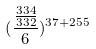<formula> <loc_0><loc_0><loc_500><loc_500>( \frac { \frac { 3 3 4 } { 3 3 2 } } { 6 } ) ^ { 3 7 + 2 5 5 }</formula> 